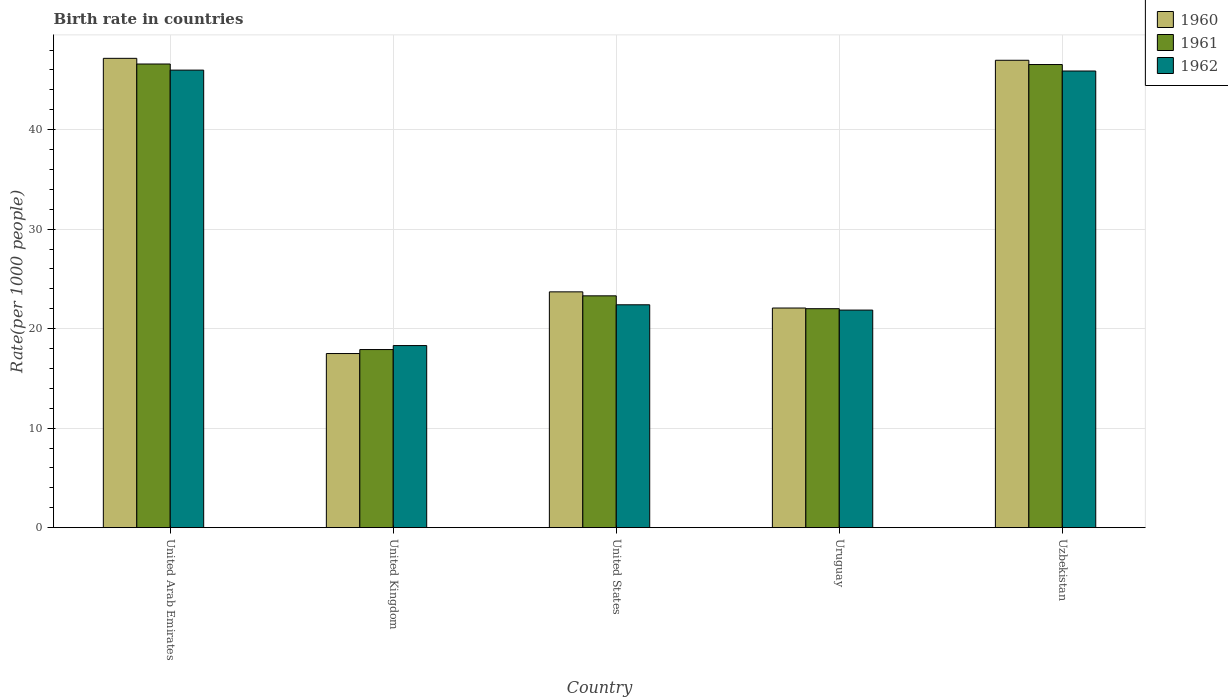How many different coloured bars are there?
Keep it short and to the point. 3. How many groups of bars are there?
Offer a terse response. 5. Are the number of bars per tick equal to the number of legend labels?
Offer a very short reply. Yes. What is the label of the 4th group of bars from the left?
Make the answer very short. Uruguay. What is the birth rate in 1962 in Uzbekistan?
Give a very brief answer. 45.9. Across all countries, what is the maximum birth rate in 1961?
Your response must be concise. 46.6. In which country was the birth rate in 1961 maximum?
Your response must be concise. United Arab Emirates. In which country was the birth rate in 1960 minimum?
Offer a terse response. United Kingdom. What is the total birth rate in 1961 in the graph?
Your answer should be very brief. 156.36. What is the difference between the birth rate in 1960 in Uruguay and that in Uzbekistan?
Make the answer very short. -24.9. What is the difference between the birth rate in 1961 in United Kingdom and the birth rate in 1960 in Uzbekistan?
Keep it short and to the point. -29.08. What is the average birth rate in 1962 per country?
Your response must be concise. 30.89. What is the difference between the birth rate of/in 1960 and birth rate of/in 1962 in Uzbekistan?
Your answer should be very brief. 1.08. In how many countries, is the birth rate in 1962 greater than 46?
Give a very brief answer. 0. What is the ratio of the birth rate in 1960 in United States to that in Uzbekistan?
Your answer should be compact. 0.5. What is the difference between the highest and the second highest birth rate in 1960?
Provide a succinct answer. -23.28. What is the difference between the highest and the lowest birth rate in 1961?
Make the answer very short. 28.7. In how many countries, is the birth rate in 1960 greater than the average birth rate in 1960 taken over all countries?
Provide a short and direct response. 2. Is the sum of the birth rate in 1960 in United States and Uzbekistan greater than the maximum birth rate in 1961 across all countries?
Ensure brevity in your answer.  Yes. How many bars are there?
Keep it short and to the point. 15. How many legend labels are there?
Make the answer very short. 3. How are the legend labels stacked?
Offer a very short reply. Vertical. What is the title of the graph?
Ensure brevity in your answer.  Birth rate in countries. Does "1998" appear as one of the legend labels in the graph?
Your response must be concise. No. What is the label or title of the X-axis?
Keep it short and to the point. Country. What is the label or title of the Y-axis?
Give a very brief answer. Rate(per 1000 people). What is the Rate(per 1000 people) in 1960 in United Arab Emirates?
Keep it short and to the point. 47.17. What is the Rate(per 1000 people) in 1961 in United Arab Emirates?
Provide a short and direct response. 46.6. What is the Rate(per 1000 people) of 1962 in United Arab Emirates?
Provide a succinct answer. 45.99. What is the Rate(per 1000 people) in 1960 in United Kingdom?
Your answer should be very brief. 17.5. What is the Rate(per 1000 people) of 1960 in United States?
Your answer should be compact. 23.7. What is the Rate(per 1000 people) of 1961 in United States?
Provide a succinct answer. 23.3. What is the Rate(per 1000 people) of 1962 in United States?
Your answer should be compact. 22.4. What is the Rate(per 1000 people) of 1960 in Uruguay?
Provide a short and direct response. 22.07. What is the Rate(per 1000 people) of 1961 in Uruguay?
Offer a very short reply. 22.01. What is the Rate(per 1000 people) in 1962 in Uruguay?
Your answer should be very brief. 21.87. What is the Rate(per 1000 people) of 1960 in Uzbekistan?
Ensure brevity in your answer.  46.98. What is the Rate(per 1000 people) of 1961 in Uzbekistan?
Your response must be concise. 46.55. What is the Rate(per 1000 people) in 1962 in Uzbekistan?
Ensure brevity in your answer.  45.9. Across all countries, what is the maximum Rate(per 1000 people) in 1960?
Provide a short and direct response. 47.17. Across all countries, what is the maximum Rate(per 1000 people) of 1961?
Your answer should be compact. 46.6. Across all countries, what is the maximum Rate(per 1000 people) of 1962?
Provide a succinct answer. 45.99. Across all countries, what is the minimum Rate(per 1000 people) of 1960?
Offer a very short reply. 17.5. Across all countries, what is the minimum Rate(per 1000 people) of 1961?
Ensure brevity in your answer.  17.9. What is the total Rate(per 1000 people) in 1960 in the graph?
Offer a very short reply. 157.42. What is the total Rate(per 1000 people) of 1961 in the graph?
Ensure brevity in your answer.  156.36. What is the total Rate(per 1000 people) in 1962 in the graph?
Make the answer very short. 154.45. What is the difference between the Rate(per 1000 people) of 1960 in United Arab Emirates and that in United Kingdom?
Ensure brevity in your answer.  29.67. What is the difference between the Rate(per 1000 people) in 1961 in United Arab Emirates and that in United Kingdom?
Offer a very short reply. 28.7. What is the difference between the Rate(per 1000 people) of 1962 in United Arab Emirates and that in United Kingdom?
Provide a succinct answer. 27.69. What is the difference between the Rate(per 1000 people) in 1960 in United Arab Emirates and that in United States?
Ensure brevity in your answer.  23.47. What is the difference between the Rate(per 1000 people) of 1961 in United Arab Emirates and that in United States?
Provide a short and direct response. 23.3. What is the difference between the Rate(per 1000 people) in 1962 in United Arab Emirates and that in United States?
Ensure brevity in your answer.  23.59. What is the difference between the Rate(per 1000 people) of 1960 in United Arab Emirates and that in Uruguay?
Keep it short and to the point. 25.1. What is the difference between the Rate(per 1000 people) of 1961 in United Arab Emirates and that in Uruguay?
Make the answer very short. 24.59. What is the difference between the Rate(per 1000 people) in 1962 in United Arab Emirates and that in Uruguay?
Offer a very short reply. 24.12. What is the difference between the Rate(per 1000 people) of 1960 in United Arab Emirates and that in Uzbekistan?
Offer a very short reply. 0.19. What is the difference between the Rate(per 1000 people) in 1961 in United Arab Emirates and that in Uzbekistan?
Ensure brevity in your answer.  0.05. What is the difference between the Rate(per 1000 people) of 1962 in United Arab Emirates and that in Uzbekistan?
Offer a terse response. 0.09. What is the difference between the Rate(per 1000 people) in 1960 in United Kingdom and that in United States?
Ensure brevity in your answer.  -6.2. What is the difference between the Rate(per 1000 people) in 1961 in United Kingdom and that in United States?
Your answer should be compact. -5.4. What is the difference between the Rate(per 1000 people) of 1962 in United Kingdom and that in United States?
Provide a short and direct response. -4.1. What is the difference between the Rate(per 1000 people) in 1960 in United Kingdom and that in Uruguay?
Your response must be concise. -4.58. What is the difference between the Rate(per 1000 people) in 1961 in United Kingdom and that in Uruguay?
Provide a short and direct response. -4.11. What is the difference between the Rate(per 1000 people) of 1962 in United Kingdom and that in Uruguay?
Make the answer very short. -3.57. What is the difference between the Rate(per 1000 people) in 1960 in United Kingdom and that in Uzbekistan?
Offer a very short reply. -29.48. What is the difference between the Rate(per 1000 people) in 1961 in United Kingdom and that in Uzbekistan?
Provide a succinct answer. -28.65. What is the difference between the Rate(per 1000 people) of 1962 in United Kingdom and that in Uzbekistan?
Provide a succinct answer. -27.6. What is the difference between the Rate(per 1000 people) of 1960 in United States and that in Uruguay?
Make the answer very short. 1.62. What is the difference between the Rate(per 1000 people) in 1961 in United States and that in Uruguay?
Make the answer very short. 1.29. What is the difference between the Rate(per 1000 people) in 1962 in United States and that in Uruguay?
Give a very brief answer. 0.53. What is the difference between the Rate(per 1000 people) in 1960 in United States and that in Uzbekistan?
Offer a very short reply. -23.28. What is the difference between the Rate(per 1000 people) in 1961 in United States and that in Uzbekistan?
Your answer should be compact. -23.25. What is the difference between the Rate(per 1000 people) of 1962 in United States and that in Uzbekistan?
Provide a short and direct response. -23.5. What is the difference between the Rate(per 1000 people) of 1960 in Uruguay and that in Uzbekistan?
Give a very brief answer. -24.9. What is the difference between the Rate(per 1000 people) of 1961 in Uruguay and that in Uzbekistan?
Your answer should be compact. -24.54. What is the difference between the Rate(per 1000 people) in 1962 in Uruguay and that in Uzbekistan?
Your answer should be very brief. -24.03. What is the difference between the Rate(per 1000 people) in 1960 in United Arab Emirates and the Rate(per 1000 people) in 1961 in United Kingdom?
Make the answer very short. 29.27. What is the difference between the Rate(per 1000 people) in 1960 in United Arab Emirates and the Rate(per 1000 people) in 1962 in United Kingdom?
Make the answer very short. 28.87. What is the difference between the Rate(per 1000 people) of 1961 in United Arab Emirates and the Rate(per 1000 people) of 1962 in United Kingdom?
Provide a succinct answer. 28.3. What is the difference between the Rate(per 1000 people) of 1960 in United Arab Emirates and the Rate(per 1000 people) of 1961 in United States?
Give a very brief answer. 23.87. What is the difference between the Rate(per 1000 people) in 1960 in United Arab Emirates and the Rate(per 1000 people) in 1962 in United States?
Give a very brief answer. 24.77. What is the difference between the Rate(per 1000 people) in 1961 in United Arab Emirates and the Rate(per 1000 people) in 1962 in United States?
Keep it short and to the point. 24.2. What is the difference between the Rate(per 1000 people) of 1960 in United Arab Emirates and the Rate(per 1000 people) of 1961 in Uruguay?
Provide a succinct answer. 25.16. What is the difference between the Rate(per 1000 people) of 1960 in United Arab Emirates and the Rate(per 1000 people) of 1962 in Uruguay?
Make the answer very short. 25.3. What is the difference between the Rate(per 1000 people) of 1961 in United Arab Emirates and the Rate(per 1000 people) of 1962 in Uruguay?
Make the answer very short. 24.73. What is the difference between the Rate(per 1000 people) of 1960 in United Arab Emirates and the Rate(per 1000 people) of 1961 in Uzbekistan?
Offer a terse response. 0.62. What is the difference between the Rate(per 1000 people) in 1960 in United Arab Emirates and the Rate(per 1000 people) in 1962 in Uzbekistan?
Offer a terse response. 1.27. What is the difference between the Rate(per 1000 people) of 1961 in United Arab Emirates and the Rate(per 1000 people) of 1962 in Uzbekistan?
Make the answer very short. 0.7. What is the difference between the Rate(per 1000 people) of 1960 in United Kingdom and the Rate(per 1000 people) of 1961 in United States?
Your answer should be very brief. -5.8. What is the difference between the Rate(per 1000 people) in 1960 in United Kingdom and the Rate(per 1000 people) in 1961 in Uruguay?
Offer a very short reply. -4.51. What is the difference between the Rate(per 1000 people) of 1960 in United Kingdom and the Rate(per 1000 people) of 1962 in Uruguay?
Provide a short and direct response. -4.37. What is the difference between the Rate(per 1000 people) in 1961 in United Kingdom and the Rate(per 1000 people) in 1962 in Uruguay?
Give a very brief answer. -3.97. What is the difference between the Rate(per 1000 people) in 1960 in United Kingdom and the Rate(per 1000 people) in 1961 in Uzbekistan?
Provide a succinct answer. -29.05. What is the difference between the Rate(per 1000 people) of 1960 in United Kingdom and the Rate(per 1000 people) of 1962 in Uzbekistan?
Your answer should be very brief. -28.4. What is the difference between the Rate(per 1000 people) of 1961 in United Kingdom and the Rate(per 1000 people) of 1962 in Uzbekistan?
Your answer should be very brief. -28. What is the difference between the Rate(per 1000 people) in 1960 in United States and the Rate(per 1000 people) in 1961 in Uruguay?
Keep it short and to the point. 1.69. What is the difference between the Rate(per 1000 people) of 1960 in United States and the Rate(per 1000 people) of 1962 in Uruguay?
Your response must be concise. 1.83. What is the difference between the Rate(per 1000 people) in 1961 in United States and the Rate(per 1000 people) in 1962 in Uruguay?
Offer a terse response. 1.43. What is the difference between the Rate(per 1000 people) in 1960 in United States and the Rate(per 1000 people) in 1961 in Uzbekistan?
Give a very brief answer. -22.85. What is the difference between the Rate(per 1000 people) of 1960 in United States and the Rate(per 1000 people) of 1962 in Uzbekistan?
Provide a short and direct response. -22.2. What is the difference between the Rate(per 1000 people) in 1961 in United States and the Rate(per 1000 people) in 1962 in Uzbekistan?
Offer a terse response. -22.6. What is the difference between the Rate(per 1000 people) in 1960 in Uruguay and the Rate(per 1000 people) in 1961 in Uzbekistan?
Your answer should be very brief. -24.47. What is the difference between the Rate(per 1000 people) of 1960 in Uruguay and the Rate(per 1000 people) of 1962 in Uzbekistan?
Your answer should be compact. -23.82. What is the difference between the Rate(per 1000 people) in 1961 in Uruguay and the Rate(per 1000 people) in 1962 in Uzbekistan?
Provide a succinct answer. -23.89. What is the average Rate(per 1000 people) of 1960 per country?
Offer a terse response. 31.48. What is the average Rate(per 1000 people) of 1961 per country?
Provide a succinct answer. 31.27. What is the average Rate(per 1000 people) in 1962 per country?
Keep it short and to the point. 30.89. What is the difference between the Rate(per 1000 people) of 1960 and Rate(per 1000 people) of 1961 in United Arab Emirates?
Give a very brief answer. 0.57. What is the difference between the Rate(per 1000 people) in 1960 and Rate(per 1000 people) in 1962 in United Arab Emirates?
Keep it short and to the point. 1.18. What is the difference between the Rate(per 1000 people) in 1961 and Rate(per 1000 people) in 1962 in United Arab Emirates?
Give a very brief answer. 0.61. What is the difference between the Rate(per 1000 people) in 1960 and Rate(per 1000 people) in 1961 in United States?
Offer a very short reply. 0.4. What is the difference between the Rate(per 1000 people) of 1960 and Rate(per 1000 people) of 1961 in Uruguay?
Ensure brevity in your answer.  0.07. What is the difference between the Rate(per 1000 people) of 1960 and Rate(per 1000 people) of 1962 in Uruguay?
Keep it short and to the point. 0.21. What is the difference between the Rate(per 1000 people) of 1961 and Rate(per 1000 people) of 1962 in Uruguay?
Provide a succinct answer. 0.14. What is the difference between the Rate(per 1000 people) in 1960 and Rate(per 1000 people) in 1961 in Uzbekistan?
Ensure brevity in your answer.  0.43. What is the difference between the Rate(per 1000 people) of 1960 and Rate(per 1000 people) of 1962 in Uzbekistan?
Offer a terse response. 1.08. What is the difference between the Rate(per 1000 people) in 1961 and Rate(per 1000 people) in 1962 in Uzbekistan?
Keep it short and to the point. 0.65. What is the ratio of the Rate(per 1000 people) of 1960 in United Arab Emirates to that in United Kingdom?
Make the answer very short. 2.7. What is the ratio of the Rate(per 1000 people) of 1961 in United Arab Emirates to that in United Kingdom?
Give a very brief answer. 2.6. What is the ratio of the Rate(per 1000 people) of 1962 in United Arab Emirates to that in United Kingdom?
Provide a succinct answer. 2.51. What is the ratio of the Rate(per 1000 people) of 1960 in United Arab Emirates to that in United States?
Provide a succinct answer. 1.99. What is the ratio of the Rate(per 1000 people) in 1961 in United Arab Emirates to that in United States?
Provide a succinct answer. 2. What is the ratio of the Rate(per 1000 people) of 1962 in United Arab Emirates to that in United States?
Your answer should be very brief. 2.05. What is the ratio of the Rate(per 1000 people) in 1960 in United Arab Emirates to that in Uruguay?
Make the answer very short. 2.14. What is the ratio of the Rate(per 1000 people) in 1961 in United Arab Emirates to that in Uruguay?
Ensure brevity in your answer.  2.12. What is the ratio of the Rate(per 1000 people) of 1962 in United Arab Emirates to that in Uruguay?
Ensure brevity in your answer.  2.1. What is the ratio of the Rate(per 1000 people) in 1960 in United Arab Emirates to that in Uzbekistan?
Your response must be concise. 1. What is the ratio of the Rate(per 1000 people) of 1961 in United Arab Emirates to that in Uzbekistan?
Ensure brevity in your answer.  1. What is the ratio of the Rate(per 1000 people) of 1960 in United Kingdom to that in United States?
Make the answer very short. 0.74. What is the ratio of the Rate(per 1000 people) in 1961 in United Kingdom to that in United States?
Give a very brief answer. 0.77. What is the ratio of the Rate(per 1000 people) in 1962 in United Kingdom to that in United States?
Ensure brevity in your answer.  0.82. What is the ratio of the Rate(per 1000 people) in 1960 in United Kingdom to that in Uruguay?
Your answer should be compact. 0.79. What is the ratio of the Rate(per 1000 people) of 1961 in United Kingdom to that in Uruguay?
Offer a very short reply. 0.81. What is the ratio of the Rate(per 1000 people) of 1962 in United Kingdom to that in Uruguay?
Provide a short and direct response. 0.84. What is the ratio of the Rate(per 1000 people) in 1960 in United Kingdom to that in Uzbekistan?
Ensure brevity in your answer.  0.37. What is the ratio of the Rate(per 1000 people) in 1961 in United Kingdom to that in Uzbekistan?
Offer a terse response. 0.38. What is the ratio of the Rate(per 1000 people) of 1962 in United Kingdom to that in Uzbekistan?
Keep it short and to the point. 0.4. What is the ratio of the Rate(per 1000 people) in 1960 in United States to that in Uruguay?
Keep it short and to the point. 1.07. What is the ratio of the Rate(per 1000 people) of 1961 in United States to that in Uruguay?
Your response must be concise. 1.06. What is the ratio of the Rate(per 1000 people) in 1962 in United States to that in Uruguay?
Offer a very short reply. 1.02. What is the ratio of the Rate(per 1000 people) of 1960 in United States to that in Uzbekistan?
Your answer should be compact. 0.5. What is the ratio of the Rate(per 1000 people) of 1961 in United States to that in Uzbekistan?
Your response must be concise. 0.5. What is the ratio of the Rate(per 1000 people) of 1962 in United States to that in Uzbekistan?
Give a very brief answer. 0.49. What is the ratio of the Rate(per 1000 people) of 1960 in Uruguay to that in Uzbekistan?
Keep it short and to the point. 0.47. What is the ratio of the Rate(per 1000 people) of 1961 in Uruguay to that in Uzbekistan?
Your answer should be very brief. 0.47. What is the ratio of the Rate(per 1000 people) in 1962 in Uruguay to that in Uzbekistan?
Keep it short and to the point. 0.48. What is the difference between the highest and the second highest Rate(per 1000 people) in 1960?
Offer a terse response. 0.19. What is the difference between the highest and the second highest Rate(per 1000 people) of 1961?
Your answer should be very brief. 0.05. What is the difference between the highest and the second highest Rate(per 1000 people) of 1962?
Provide a succinct answer. 0.09. What is the difference between the highest and the lowest Rate(per 1000 people) in 1960?
Make the answer very short. 29.67. What is the difference between the highest and the lowest Rate(per 1000 people) of 1961?
Ensure brevity in your answer.  28.7. What is the difference between the highest and the lowest Rate(per 1000 people) in 1962?
Keep it short and to the point. 27.69. 